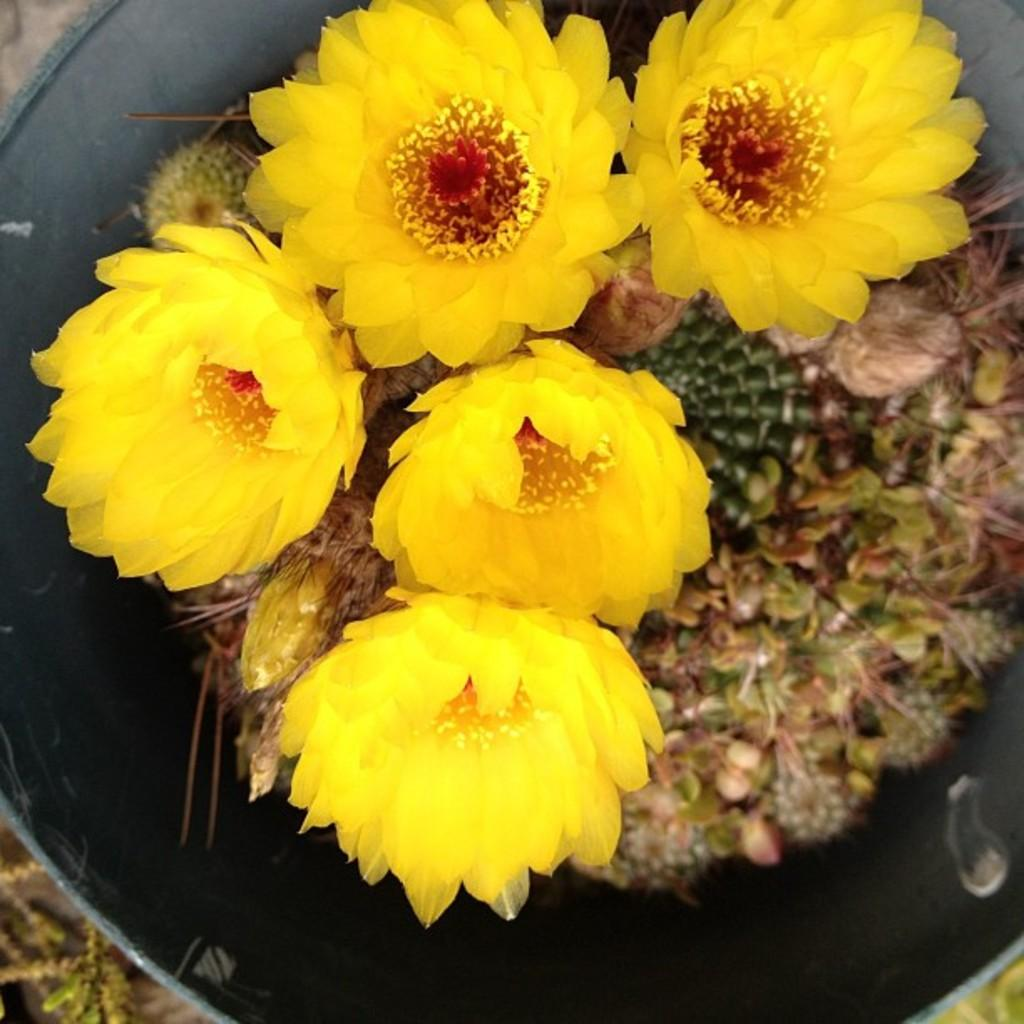What type of flowers can be seen in the image? There are yellow color flowers in the image. What type of chalk is being used to draw on the flowers in the image? There is no chalk or drawing present in the image; it only features yellow color flowers. 